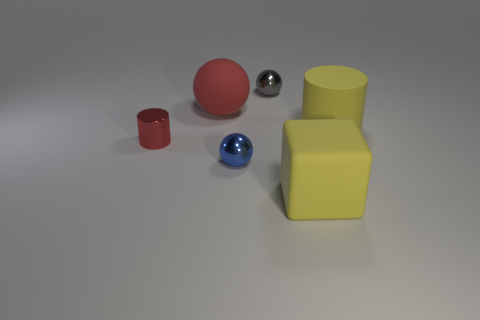Are there any other things that are the same size as the gray thing?
Offer a terse response. Yes. The object that is the same color as the big cylinder is what shape?
Your response must be concise. Cube. Do the big thing left of the gray sphere and the small cylinder have the same color?
Provide a succinct answer. Yes. Are there any other things that have the same color as the small metal cylinder?
Make the answer very short. Yes. Are there more large matte balls behind the metal cylinder than tiny brown metallic cylinders?
Offer a terse response. Yes. Are there any small blue matte balls?
Ensure brevity in your answer.  No. How many other things are the same shape as the red metallic thing?
Offer a terse response. 1. There is a cylinder to the right of the matte sphere; is it the same color as the large block that is in front of the small blue sphere?
Make the answer very short. Yes. What is the size of the metal ball in front of the small metallic sphere that is behind the large rubber thing that is to the left of the small blue shiny sphere?
Ensure brevity in your answer.  Small. There is a thing that is to the right of the large red sphere and behind the matte cylinder; what shape is it?
Your answer should be very brief. Sphere. 